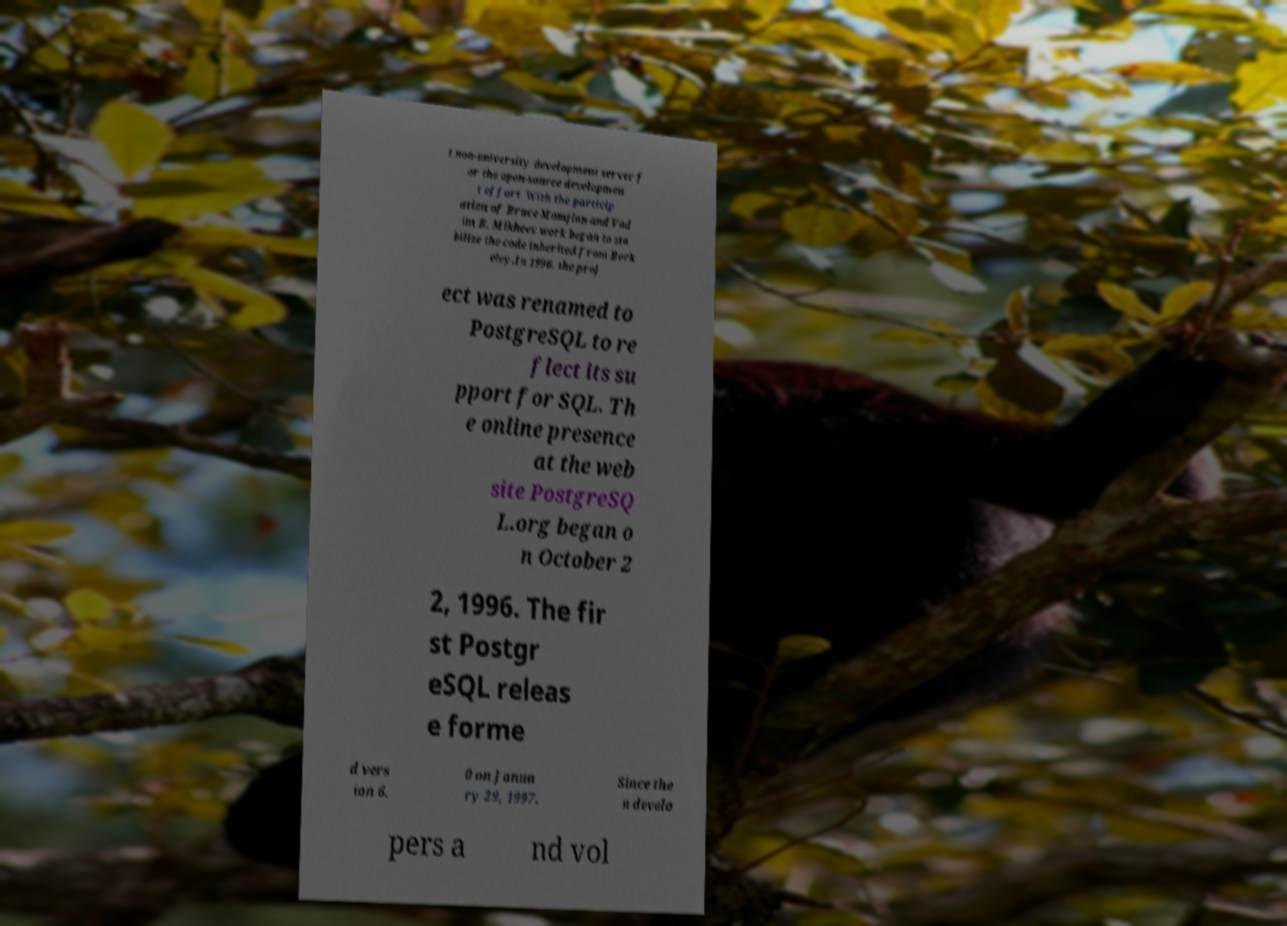Can you accurately transcribe the text from the provided image for me? t non-university development server f or the open-source developmen t effort. With the particip ation of Bruce Momjian and Vad im B. Mikheev work began to sta bilize the code inherited from Berk eley.In 1996, the proj ect was renamed to PostgreSQL to re flect its su pport for SQL. Th e online presence at the web site PostgreSQ L.org began o n October 2 2, 1996. The fir st Postgr eSQL releas e forme d vers ion 6. 0 on Janua ry 29, 1997. Since the n develo pers a nd vol 